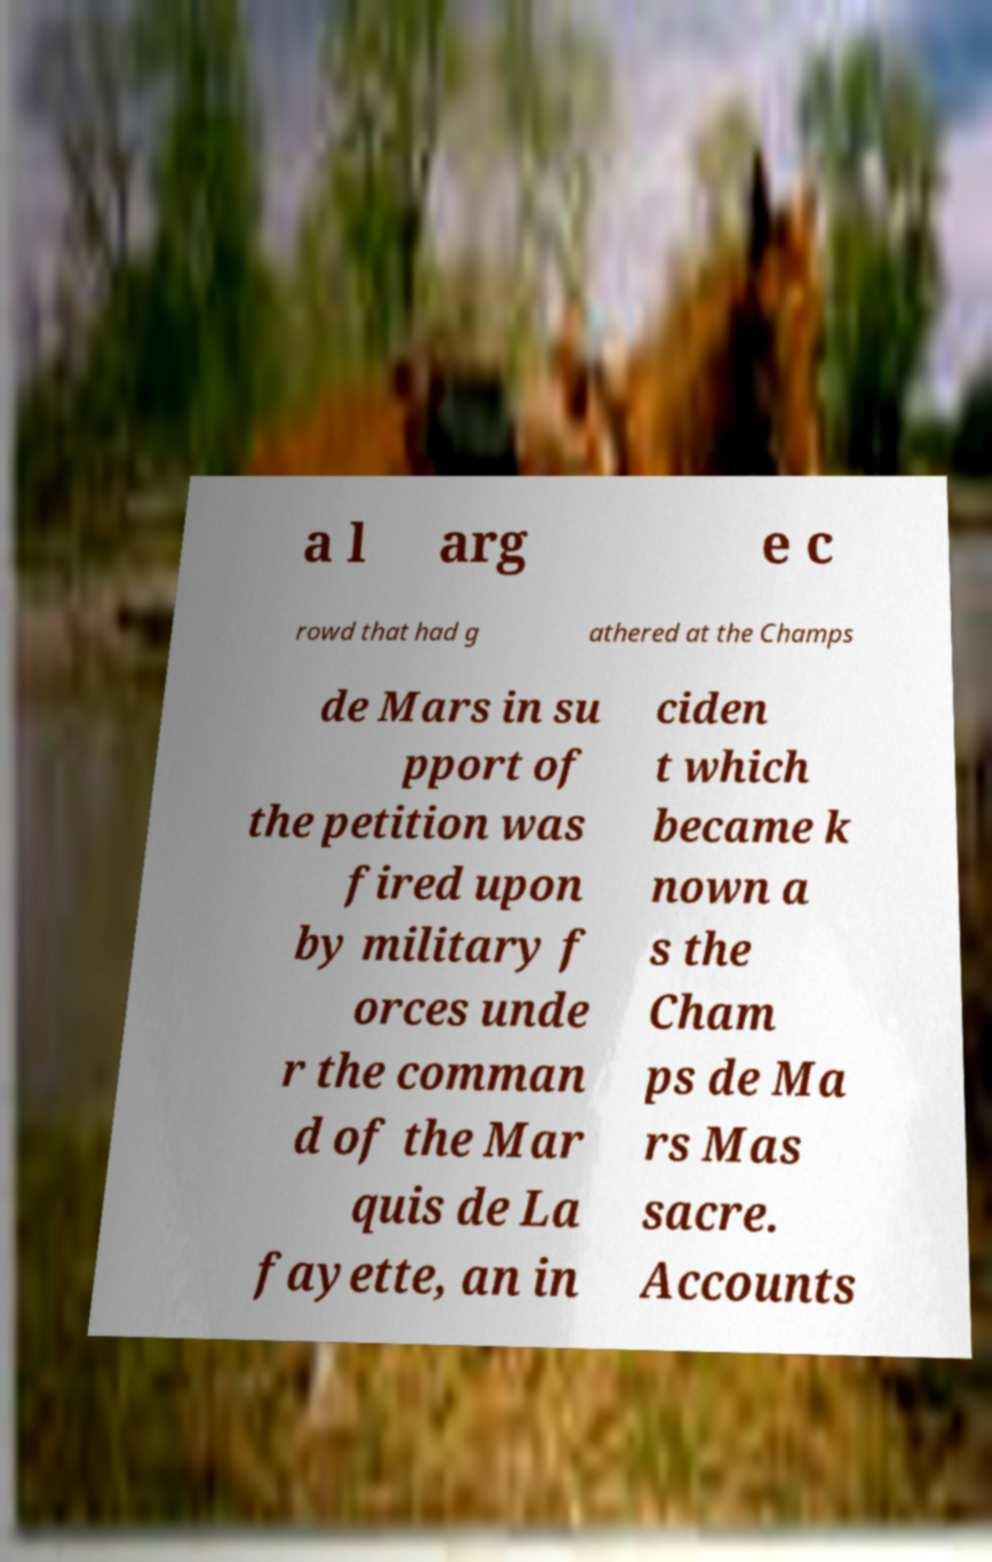What messages or text are displayed in this image? I need them in a readable, typed format. a l arg e c rowd that had g athered at the Champs de Mars in su pport of the petition was fired upon by military f orces unde r the comman d of the Mar quis de La fayette, an in ciden t which became k nown a s the Cham ps de Ma rs Mas sacre. Accounts 